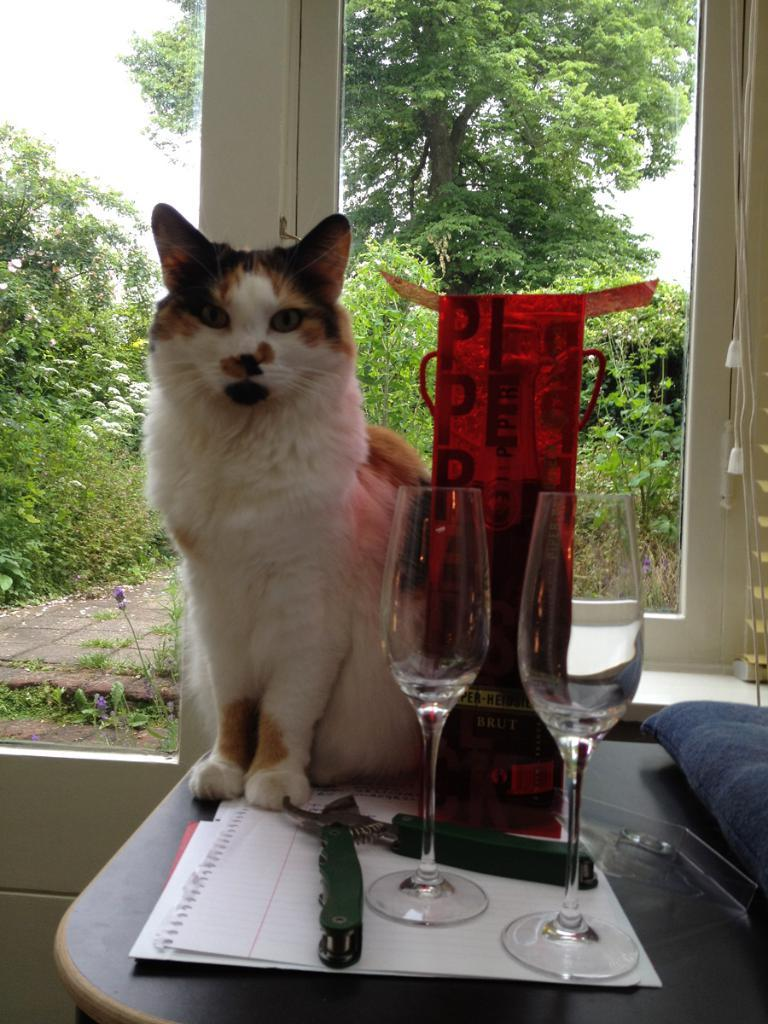What is the main object in the center of the image? There is a table in the center of the image. What type of animal is on the table? A cat is present on the table. What items are on the table with the cat? There are wine glasses and papers visible on the table. What can be seen in the background of the image? There is a window, trees, and the sky visible in the background of the image. Can you describe the objects around the cat on the table? The specific nature of the objects around the cat is not clear from the transcript. How many bags of prose can be seen on the table? There are no bags or prose present in the image. What type of lizards are crawling on the cat? There are no lizards present in the image. 